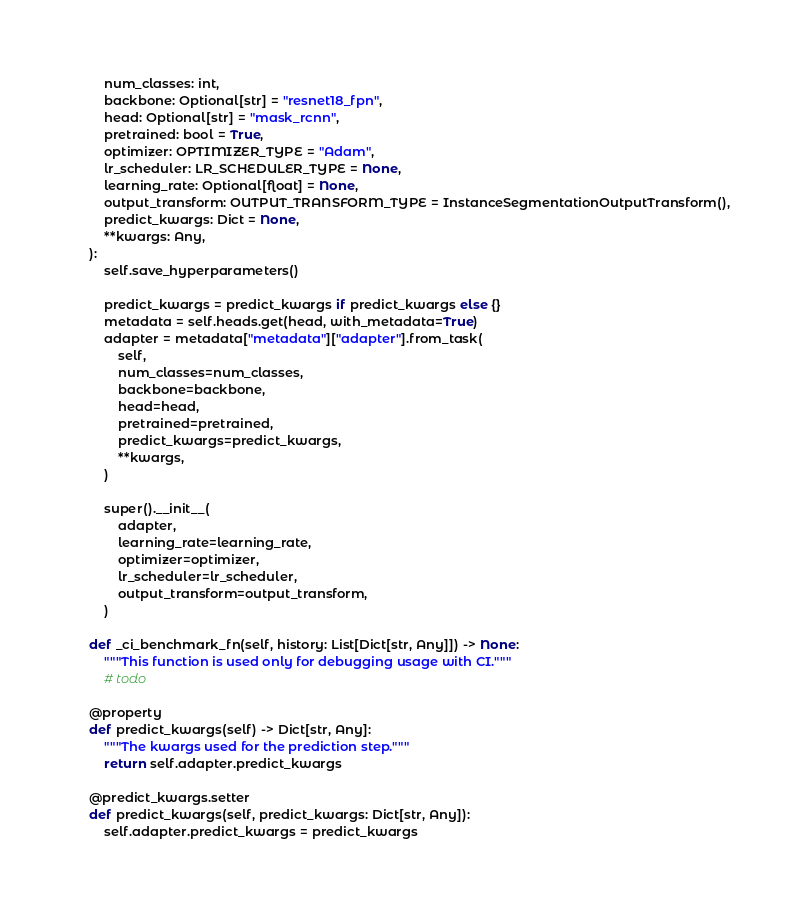<code> <loc_0><loc_0><loc_500><loc_500><_Python_>        num_classes: int,
        backbone: Optional[str] = "resnet18_fpn",
        head: Optional[str] = "mask_rcnn",
        pretrained: bool = True,
        optimizer: OPTIMIZER_TYPE = "Adam",
        lr_scheduler: LR_SCHEDULER_TYPE = None,
        learning_rate: Optional[float] = None,
        output_transform: OUTPUT_TRANSFORM_TYPE = InstanceSegmentationOutputTransform(),
        predict_kwargs: Dict = None,
        **kwargs: Any,
    ):
        self.save_hyperparameters()

        predict_kwargs = predict_kwargs if predict_kwargs else {}
        metadata = self.heads.get(head, with_metadata=True)
        adapter = metadata["metadata"]["adapter"].from_task(
            self,
            num_classes=num_classes,
            backbone=backbone,
            head=head,
            pretrained=pretrained,
            predict_kwargs=predict_kwargs,
            **kwargs,
        )

        super().__init__(
            adapter,
            learning_rate=learning_rate,
            optimizer=optimizer,
            lr_scheduler=lr_scheduler,
            output_transform=output_transform,
        )

    def _ci_benchmark_fn(self, history: List[Dict[str, Any]]) -> None:
        """This function is used only for debugging usage with CI."""
        # todo

    @property
    def predict_kwargs(self) -> Dict[str, Any]:
        """The kwargs used for the prediction step."""
        return self.adapter.predict_kwargs

    @predict_kwargs.setter
    def predict_kwargs(self, predict_kwargs: Dict[str, Any]):
        self.adapter.predict_kwargs = predict_kwargs
</code> 